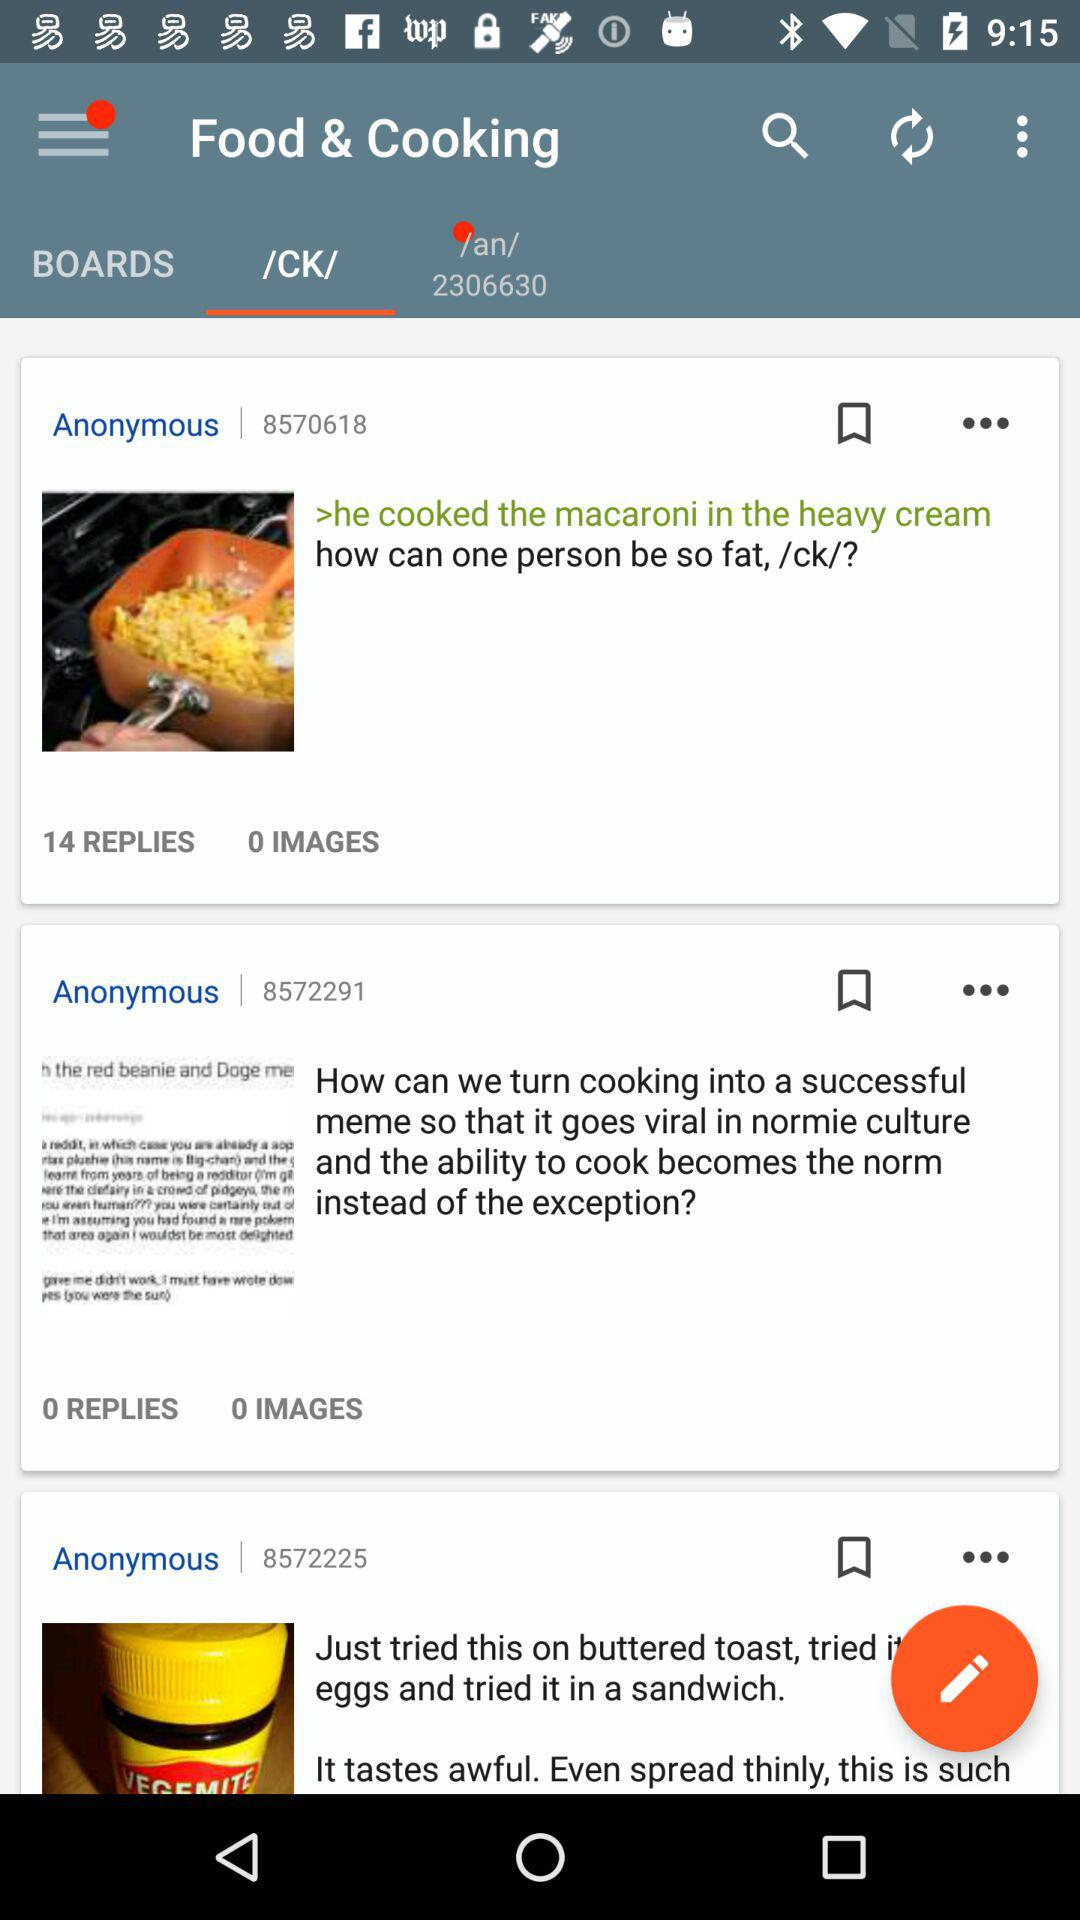How many people have replied to "how can one person be so fat, /ck/?"? The number of people who replied to "how can one person be so fat, /ck/?" is 14. 